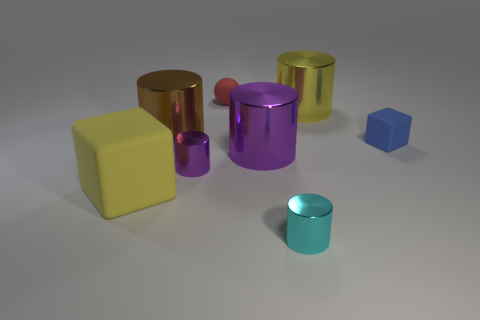Subtract all yellow cylinders. How many cylinders are left? 4 Add 2 tiny cylinders. How many objects exist? 10 Subtract all gray blocks. How many purple cylinders are left? 2 Subtract all brown cylinders. How many cylinders are left? 4 Subtract all cylinders. How many objects are left? 3 Add 7 tiny red rubber spheres. How many tiny red rubber spheres are left? 8 Add 4 yellow rubber things. How many yellow rubber things exist? 5 Subtract 1 yellow blocks. How many objects are left? 7 Subtract 2 cubes. How many cubes are left? 0 Subtract all green cylinders. Subtract all brown blocks. How many cylinders are left? 5 